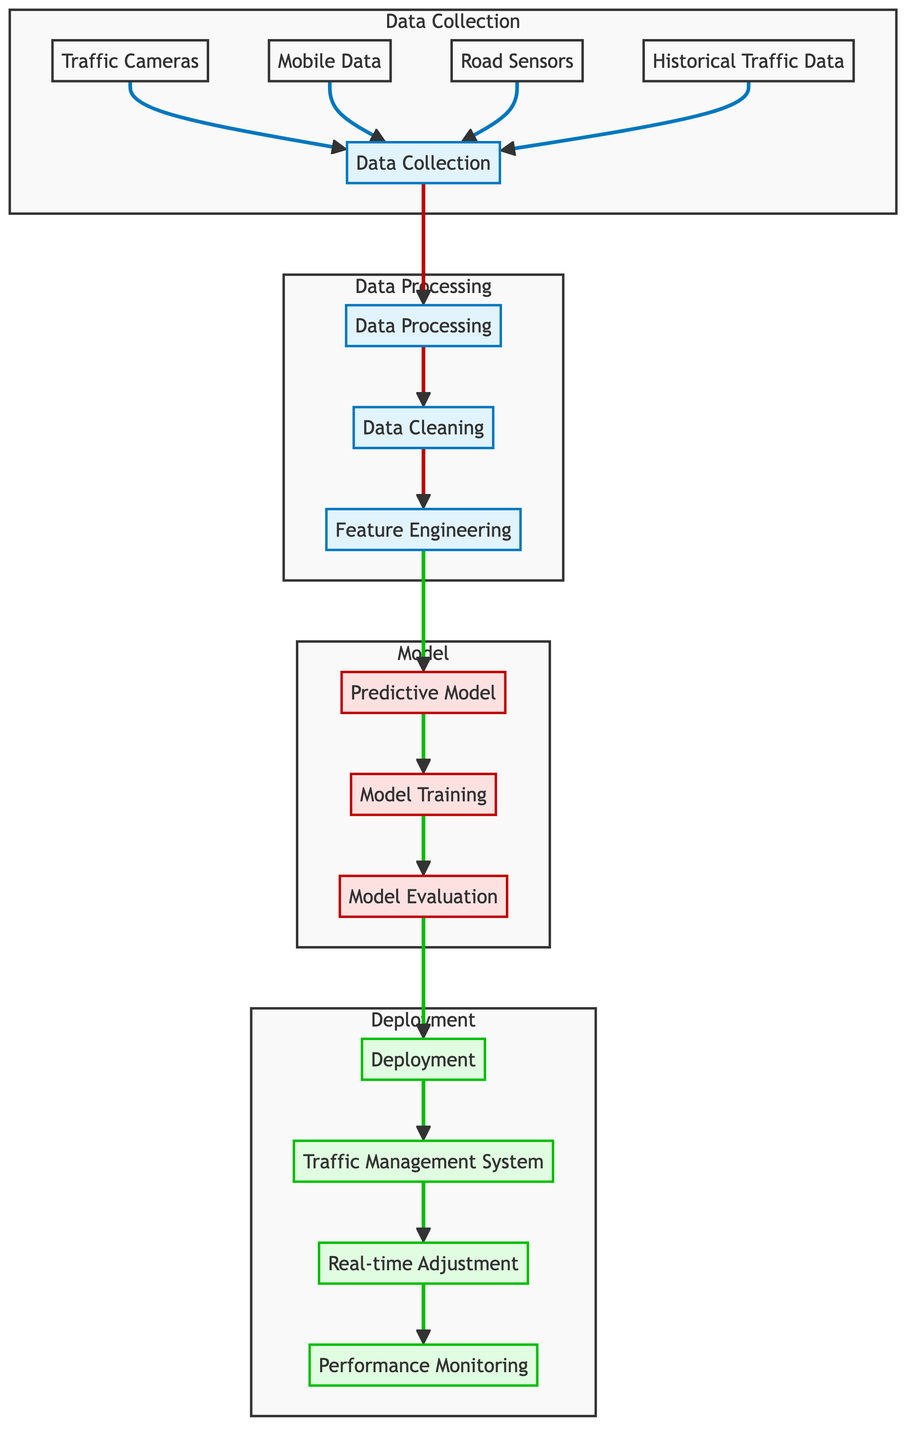What are the components involved in data collection? The diagram lists four components under 'Data Collection': Traffic Cameras, Mobile Data, Road Sensors, and Historical Traffic Data.
Answer: Traffic Cameras, Mobile Data, Road Sensors, Historical Traffic Data How many nodes are in the 'Data Processing' subgraph? The 'Data Processing' subgraph contains three nodes: Data Cleaning, Feature Engineering, and Data Processing itself.
Answer: 3 What is the final step in the flowchart? The last node in the flowchart represents 'Performance Monitoring' that follows after 'Real-time Adjustment'.
Answer: Performance Monitoring Which node follows 'Model Evaluation'? The flow diagram indicates that 'Deployment' is the next step after 'Model Evaluation', showing the transition from model assessment to system implementation.
Answer: Deployment What type of system is involved in deployment? The diagram identifies 'Traffic Management System' as the primary system involved in the deployment phase.
Answer: Traffic Management System What is the purpose of 'Feature Engineering'? 'Feature Engineering' focuses on transforming raw data into features suitable for predictive modeling, acting as a bridge between data processing and model creation.
Answer: Transforming data into features How many edges lead into the 'Predictive Model'? The 'Predictive Model' node receives input from one node, which is 'Feature Engineering', indicating a singular flow path into this modeling step.
Answer: 1 What is the main action performed in 'Model Training'? 'Model Training' represents the process of teaching the predictive model how to interpret the input features based on historical data.
Answer: Teaching the model Which two nodes are involved in real-time traffic adjustments? The flowchart indicates that 'Traffic Management System' feeds into 'Real-time Adjustment', highlighting the link between the management system and operational changes.
Answer: Traffic Management System, Real-time Adjustment 